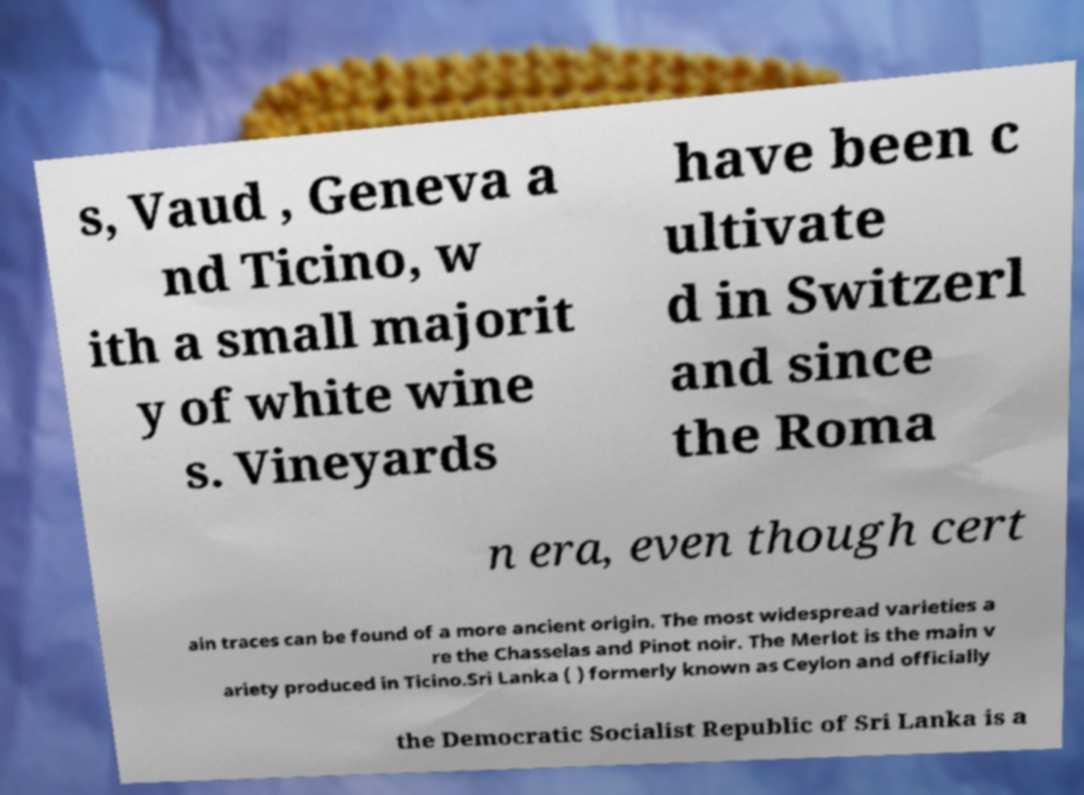Could you assist in decoding the text presented in this image and type it out clearly? s, Vaud , Geneva a nd Ticino, w ith a small majorit y of white wine s. Vineyards have been c ultivate d in Switzerl and since the Roma n era, even though cert ain traces can be found of a more ancient origin. The most widespread varieties a re the Chasselas and Pinot noir. The Merlot is the main v ariety produced in Ticino.Sri Lanka ( ) formerly known as Ceylon and officially the Democratic Socialist Republic of Sri Lanka is a 